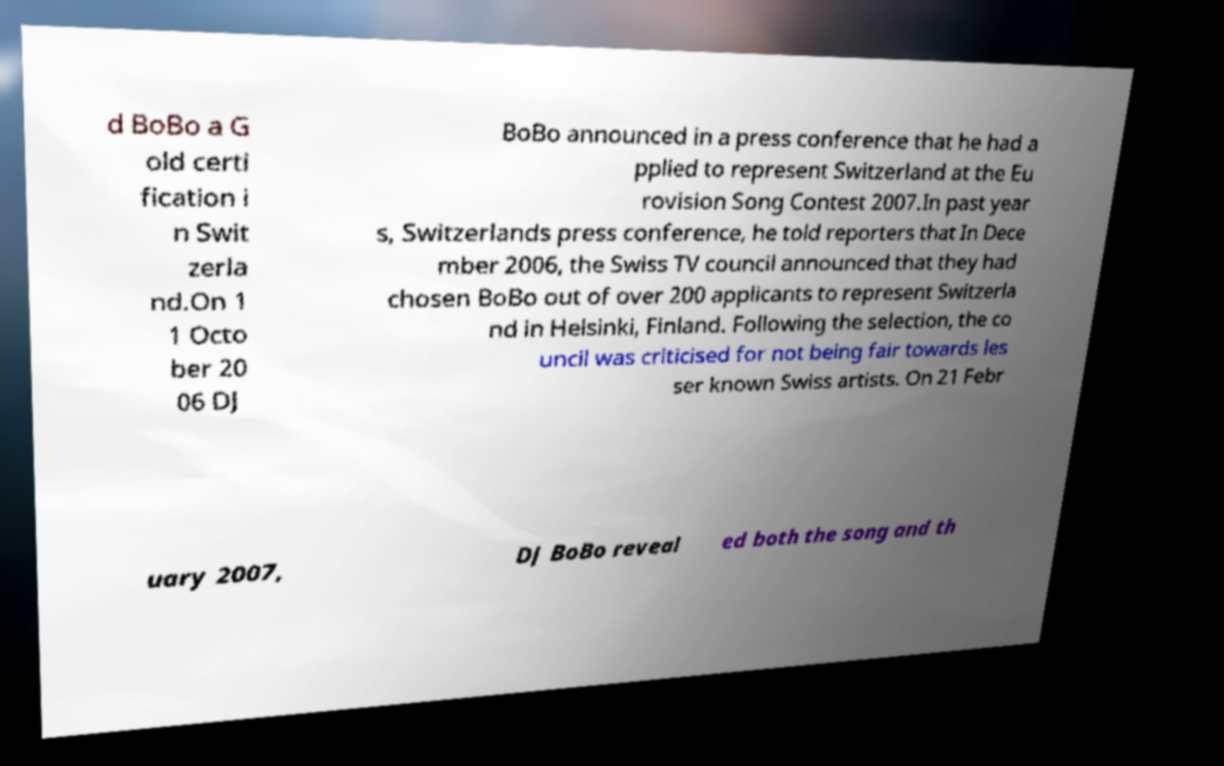Could you extract and type out the text from this image? d BoBo a G old certi fication i n Swit zerla nd.On 1 1 Octo ber 20 06 DJ BoBo announced in a press conference that he had a pplied to represent Switzerland at the Eu rovision Song Contest 2007.In past year s, Switzerlands press conference, he told reporters that In Dece mber 2006, the Swiss TV council announced that they had chosen BoBo out of over 200 applicants to represent Switzerla nd in Helsinki, Finland. Following the selection, the co uncil was criticised for not being fair towards les ser known Swiss artists. On 21 Febr uary 2007, DJ BoBo reveal ed both the song and th 